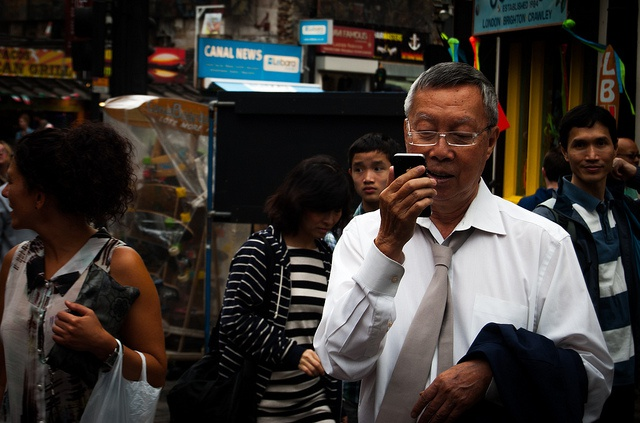Describe the objects in this image and their specific colors. I can see people in black, lightgray, maroon, and darkgray tones, people in black, maroon, and gray tones, people in black, gray, and darkgray tones, people in black, gray, maroon, and darkgray tones, and tie in black, gray, and darkgray tones in this image. 